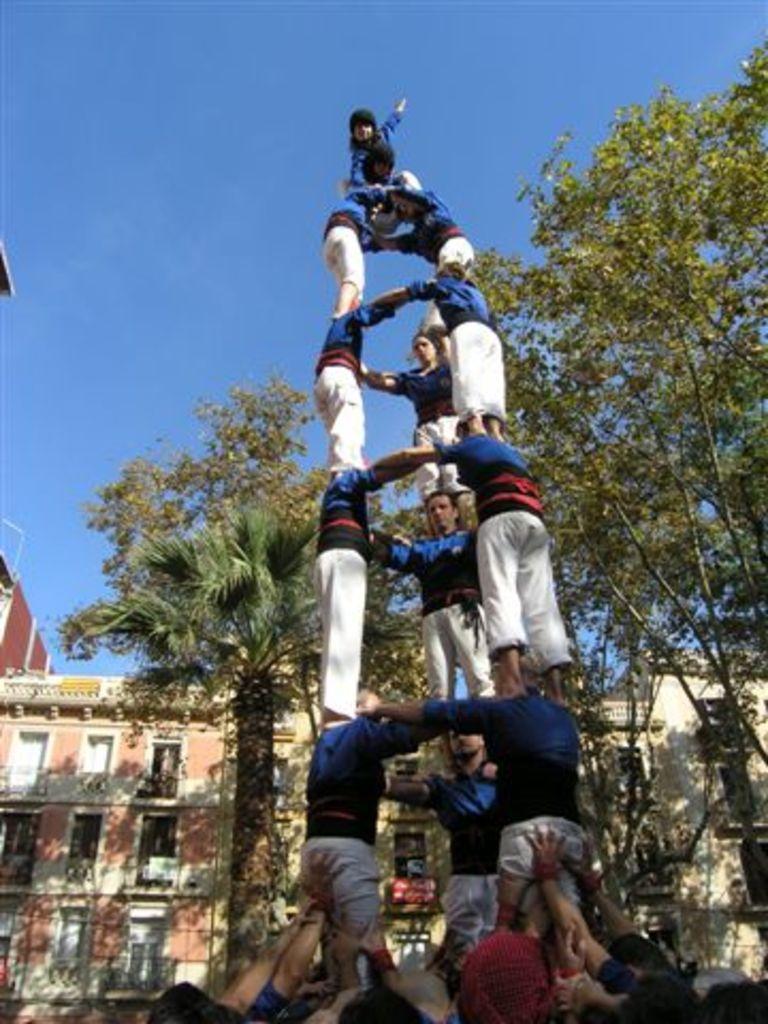Please provide a concise description of this image. In this image, we can see some people, there are some green color trees, there are some buildings, at the top there is a blue color sky. 